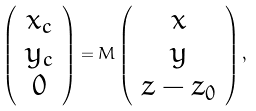Convert formula to latex. <formula><loc_0><loc_0><loc_500><loc_500>\left ( \begin{array} { c } x _ { c } \\ y _ { c } \\ 0 \end{array} \right ) = M \left ( \begin{array} { c } x \\ y \\ z - z _ { 0 } \end{array} \right ) ,</formula> 